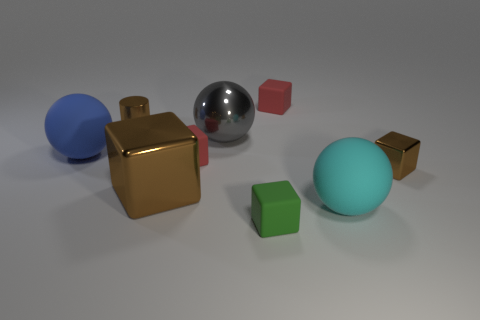There is a cyan object that is the same size as the blue matte thing; what is it made of?
Offer a terse response. Rubber. How many tiny objects are either blocks or green balls?
Make the answer very short. 4. Are there any tiny green blocks?
Your response must be concise. Yes. What size is the brown cube that is the same material as the large brown object?
Make the answer very short. Small. Do the small brown cylinder and the gray sphere have the same material?
Keep it short and to the point. Yes. How many other things are there of the same material as the small brown cube?
Offer a terse response. 3. What number of tiny cubes are behind the large cyan ball and left of the large cyan ball?
Your answer should be compact. 2. The big metal ball has what color?
Your response must be concise. Gray. There is a big blue object that is the same shape as the gray metallic thing; what material is it?
Keep it short and to the point. Rubber. Is the big metal block the same color as the metallic cylinder?
Offer a terse response. Yes. 